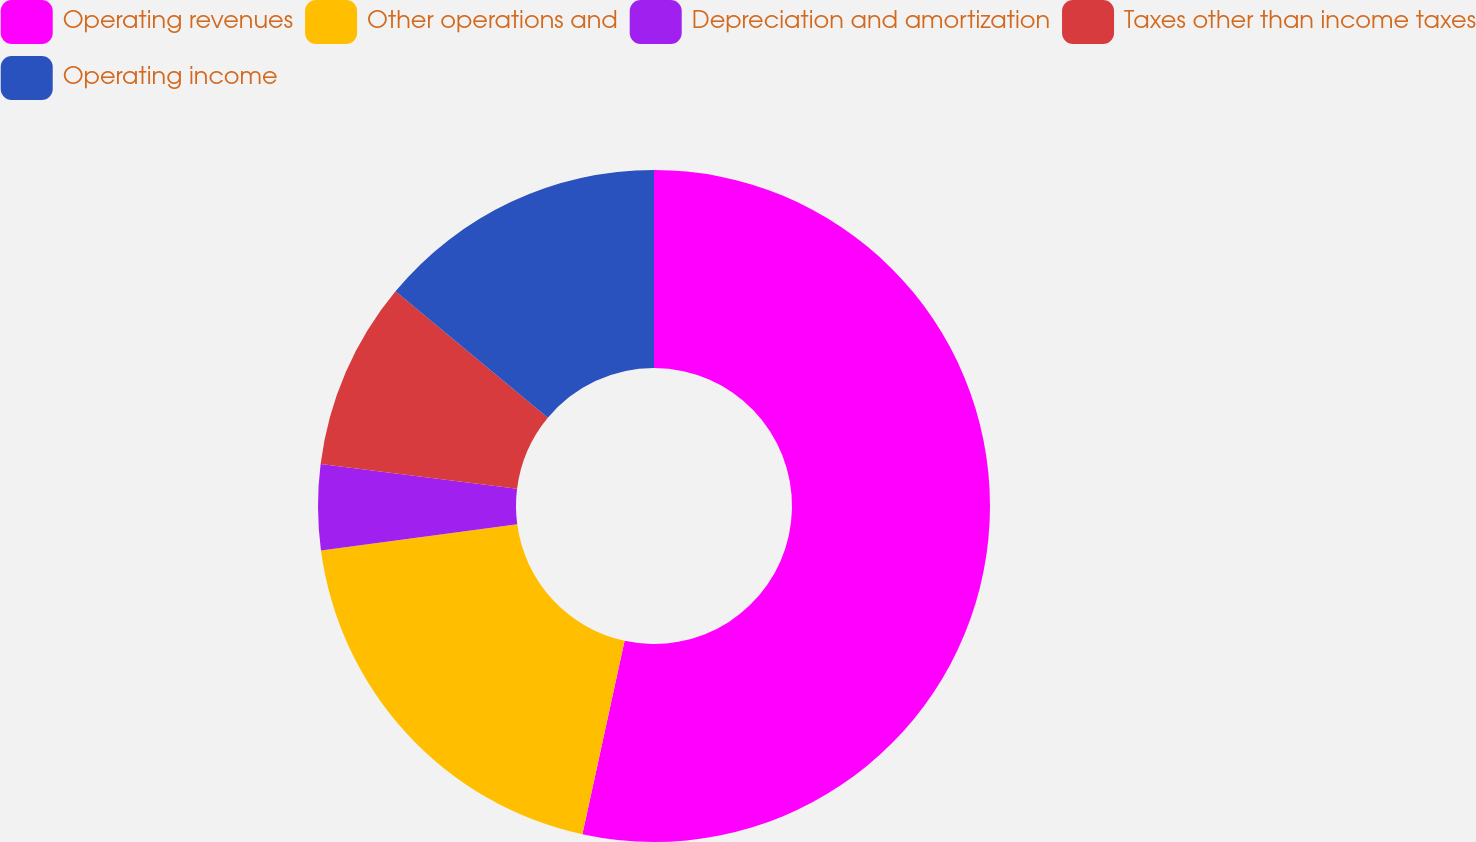<chart> <loc_0><loc_0><loc_500><loc_500><pie_chart><fcel>Operating revenues<fcel>Other operations and<fcel>Depreciation and amortization<fcel>Taxes other than income taxes<fcel>Operating income<nl><fcel>53.42%<fcel>19.46%<fcel>4.11%<fcel>9.04%<fcel>13.97%<nl></chart> 